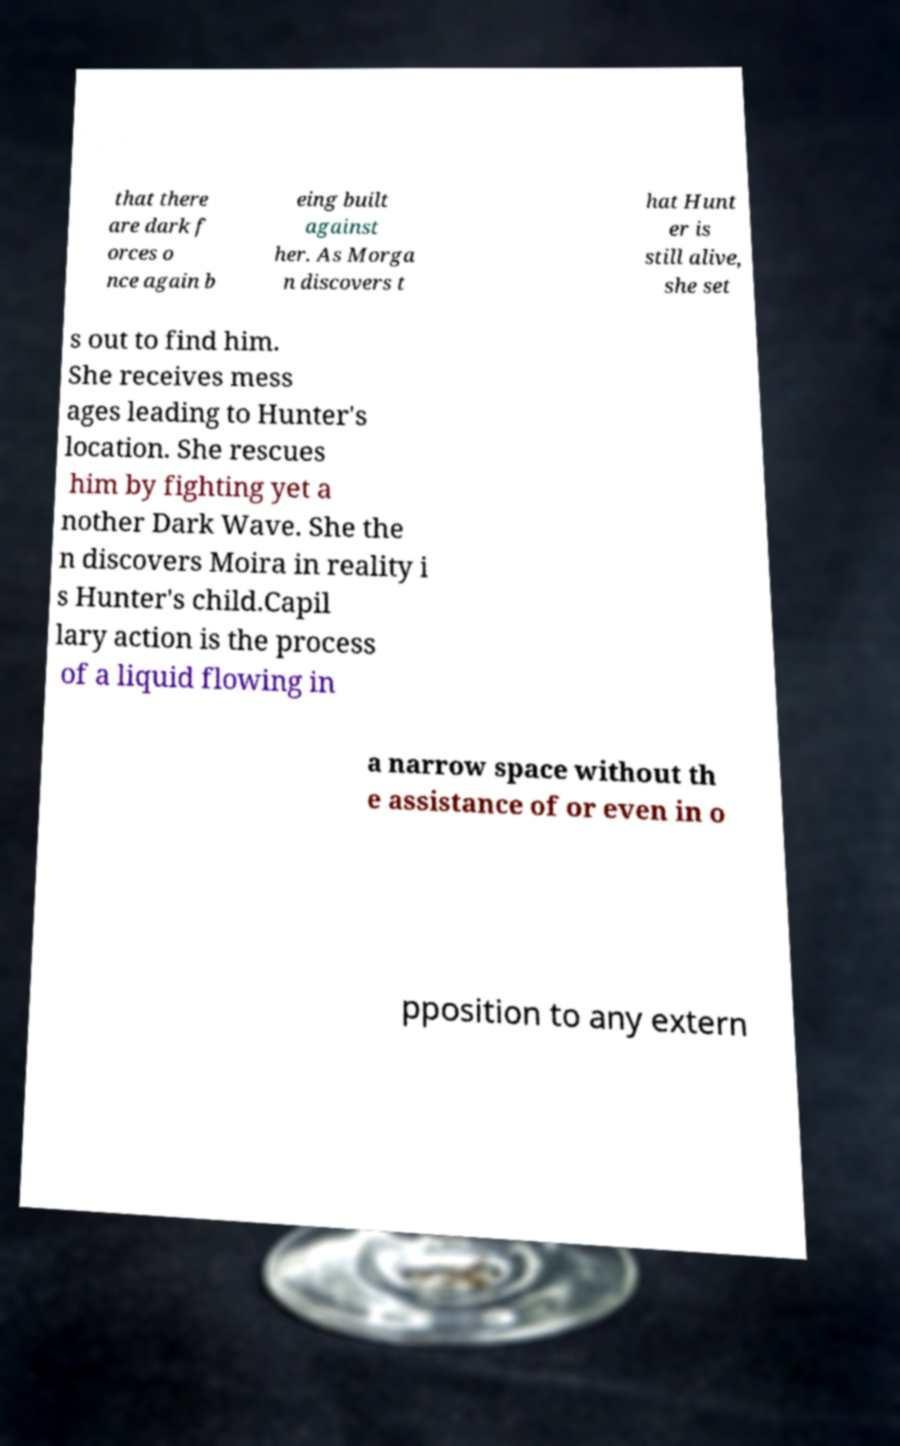Could you assist in decoding the text presented in this image and type it out clearly? that there are dark f orces o nce again b eing built against her. As Morga n discovers t hat Hunt er is still alive, she set s out to find him. She receives mess ages leading to Hunter's location. She rescues him by fighting yet a nother Dark Wave. She the n discovers Moira in reality i s Hunter's child.Capil lary action is the process of a liquid flowing in a narrow space without th e assistance of or even in o pposition to any extern 